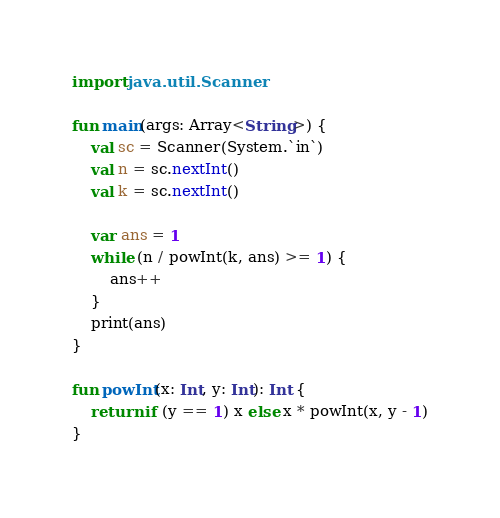Convert code to text. <code><loc_0><loc_0><loc_500><loc_500><_Kotlin_>import java.util.Scanner

fun main(args: Array<String>) {
    val sc = Scanner(System.`in`)
    val n = sc.nextInt()
    val k = sc.nextInt()

    var ans = 1
    while (n / powInt(k, ans) >= 1) {
        ans++
    }
    print(ans)
}

fun powInt(x: Int, y: Int): Int {
    return if (y == 1) x else x * powInt(x, y - 1)
}
</code> 